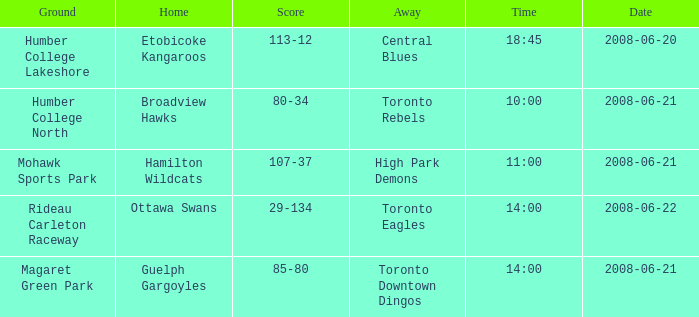Would you be able to parse every entry in this table? {'header': ['Ground', 'Home', 'Score', 'Away', 'Time', 'Date'], 'rows': [['Humber College Lakeshore', 'Etobicoke Kangaroos', '113-12', 'Central Blues', '18:45', '2008-06-20'], ['Humber College North', 'Broadview Hawks', '80-34', 'Toronto Rebels', '10:00', '2008-06-21'], ['Mohawk Sports Park', 'Hamilton Wildcats', '107-37', 'High Park Demons', '11:00', '2008-06-21'], ['Rideau Carleton Raceway', 'Ottawa Swans', '29-134', 'Toronto Eagles', '14:00', '2008-06-22'], ['Magaret Green Park', 'Guelph Gargoyles', '85-80', 'Toronto Downtown Dingos', '14:00', '2008-06-21']]} What is the Time with a Score that is 80-34? 10:00. 